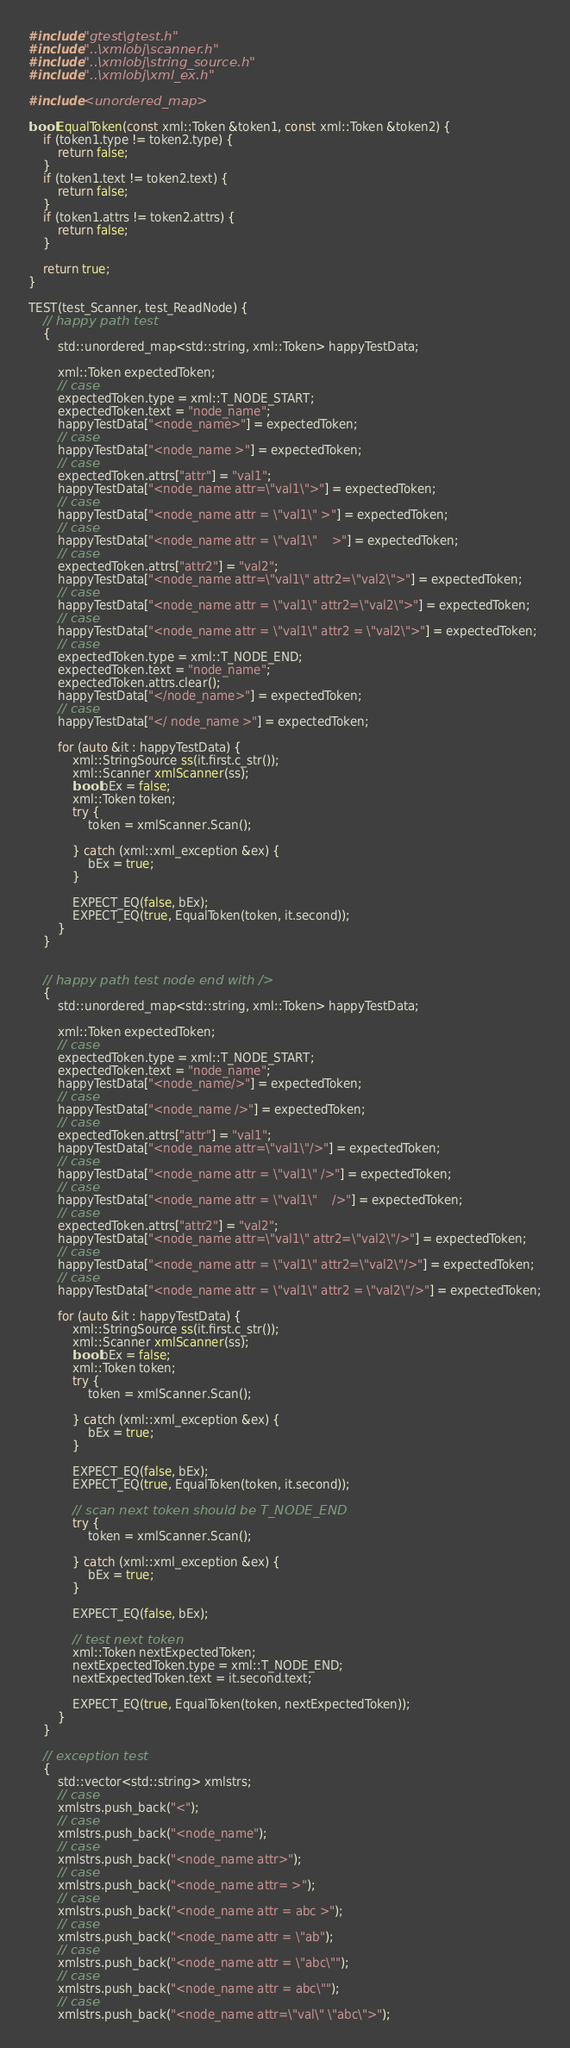<code> <loc_0><loc_0><loc_500><loc_500><_C++_>#include "gtest\gtest.h"
#include "..\xmlobj\scanner.h"
#include "..\xmlobj\string_source.h"
#include "..\xmlobj\xml_ex.h"

#include <unordered_map>

bool EqualToken(const xml::Token &token1, const xml::Token &token2) {
	if (token1.type != token2.type) {
		return false;
	}
	if (token1.text != token2.text) {
		return false;
	}
	if (token1.attrs != token2.attrs) {
		return false;
	}

	return true;
}

TEST(test_Scanner, test_ReadNode) {
	// happy path test
	{
		std::unordered_map<std::string, xml::Token> happyTestData;

		xml::Token expectedToken; 
		// case
		expectedToken.type = xml::T_NODE_START;
		expectedToken.text = "node_name";
		happyTestData["<node_name>"] = expectedToken;
		// case
		happyTestData["<node_name >"] = expectedToken;
		// case
		expectedToken.attrs["attr"] = "val1";
		happyTestData["<node_name attr=\"val1\">"] = expectedToken;
		// case
		happyTestData["<node_name attr = \"val1\" >"] = expectedToken;
		// case
		happyTestData["<node_name attr = \"val1\"	>"] = expectedToken;
		// case
		expectedToken.attrs["attr2"] = "val2";
		happyTestData["<node_name attr=\"val1\" attr2=\"val2\">"] = expectedToken;
		// case
		happyTestData["<node_name attr = \"val1\" attr2=\"val2\">"] = expectedToken;
		// case
		happyTestData["<node_name attr = \"val1\" attr2 = \"val2\">"] = expectedToken;
		// case 
		expectedToken.type = xml::T_NODE_END;
		expectedToken.text = "node_name";
		expectedToken.attrs.clear();
		happyTestData["</node_name>"] = expectedToken;
		// case
		happyTestData["</ node_name >"] = expectedToken;

		for (auto &it : happyTestData) {
			xml::StringSource ss(it.first.c_str());
			xml::Scanner xmlScanner(ss);
			bool bEx = false;
			xml::Token token;
			try {
				token = xmlScanner.Scan();

			} catch (xml::xml_exception &ex) {
				bEx = true;
			}

			EXPECT_EQ(false, bEx);
			EXPECT_EQ(true, EqualToken(token, it.second));
		}
	}


	// happy path test node end with />
	{
		std::unordered_map<std::string, xml::Token> happyTestData;

		xml::Token expectedToken;
		// case
		expectedToken.type = xml::T_NODE_START;
		expectedToken.text = "node_name";
		happyTestData["<node_name/>"] = expectedToken;
		// case
		happyTestData["<node_name />"] = expectedToken;
		// case
		expectedToken.attrs["attr"] = "val1";
		happyTestData["<node_name attr=\"val1\"/>"] = expectedToken;
		// case
		happyTestData["<node_name attr = \"val1\" />"] = expectedToken;
		// case
		happyTestData["<node_name attr = \"val1\"	/>"] = expectedToken;
		// case
		expectedToken.attrs["attr2"] = "val2";
		happyTestData["<node_name attr=\"val1\" attr2=\"val2\"/>"] = expectedToken;
		// case
		happyTestData["<node_name attr = \"val1\" attr2=\"val2\"/>"] = expectedToken;
		// case
		happyTestData["<node_name attr = \"val1\" attr2 = \"val2\"/>"] = expectedToken;

		for (auto &it : happyTestData) {
			xml::StringSource ss(it.first.c_str());
			xml::Scanner xmlScanner(ss);
			bool bEx = false;
			xml::Token token;
			try {
				token = xmlScanner.Scan();

			} catch (xml::xml_exception &ex) {
				bEx = true;
			}

			EXPECT_EQ(false, bEx);
			EXPECT_EQ(true, EqualToken(token, it.second));

			// scan next token should be T_NODE_END
			try {
				token = xmlScanner.Scan();

			} catch (xml::xml_exception &ex) {
				bEx = true;
			}

			EXPECT_EQ(false, bEx);
			
			// test next token
			xml::Token nextExpectedToken;
			nextExpectedToken.type = xml::T_NODE_END;
			nextExpectedToken.text = it.second.text;

			EXPECT_EQ(true, EqualToken(token, nextExpectedToken));
		}
	}

	// exception test
	{
		std::vector<std::string> xmlstrs;
		// case
		xmlstrs.push_back("<");	
		// case
		xmlstrs.push_back("<node_name");
		// case
		xmlstrs.push_back("<node_name attr>");
		// case
		xmlstrs.push_back("<node_name attr= >");
		// case
		xmlstrs.push_back("<node_name attr = abc >");
		// case
		xmlstrs.push_back("<node_name attr = \"ab");
		// case
		xmlstrs.push_back("<node_name attr = \"abc\"");
		// case
		xmlstrs.push_back("<node_name attr = abc\"");
		// case
		xmlstrs.push_back("<node_name attr=\"val\" \"abc\">");</code> 